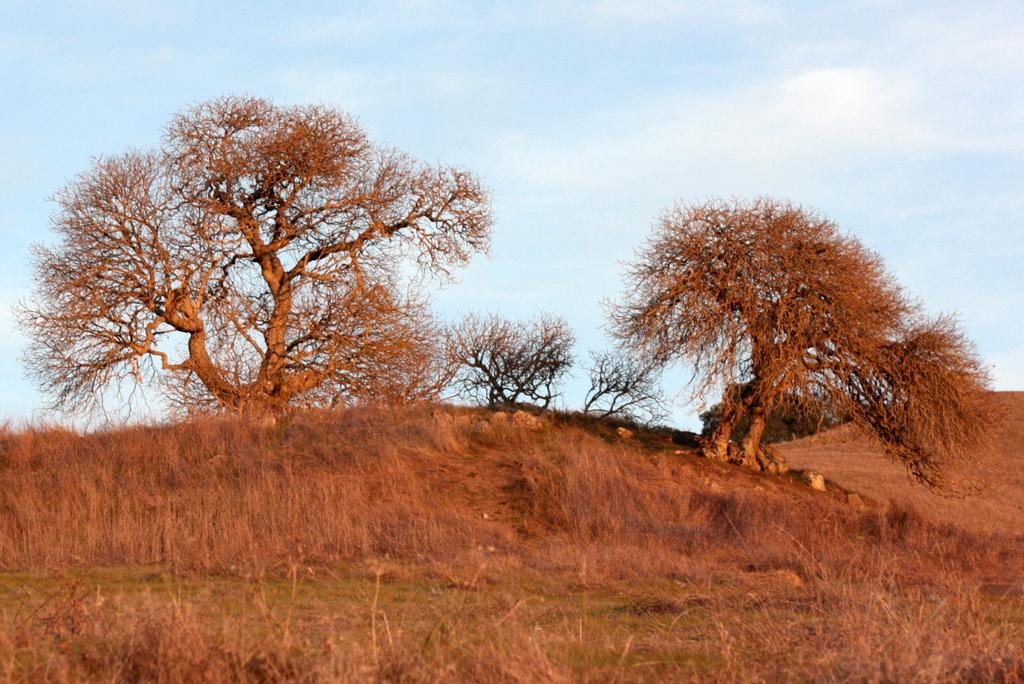What type of vegetation is at the bottom of the image? There is grass and plants at the bottom of the image. What can be seen in the background of the image? There are trees and rocks in the background of the image. What is visible at the top of the image? The sky is visible at the top of the image. How many oranges are hanging from the trees in the image? There are no oranges present in the image; it features trees and rocks in the background. Can you describe the bat flying in the sky in the image? There is no bat present in the image; only grass, plants, trees, rocks, and the sky are visible. 